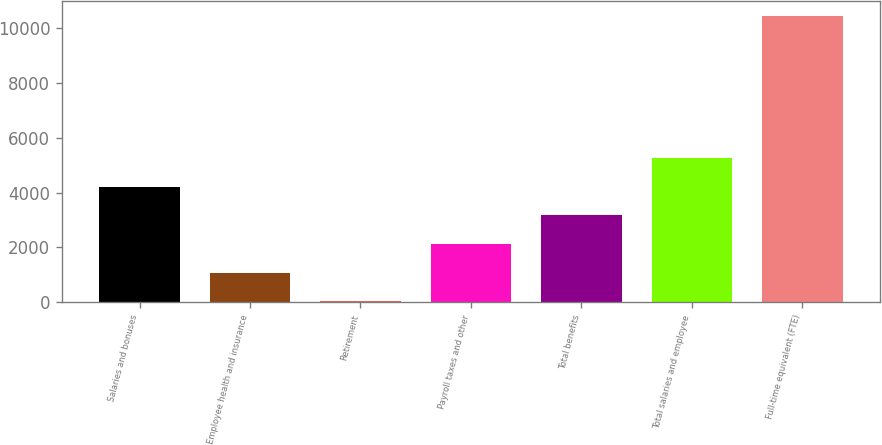Convert chart. <chart><loc_0><loc_0><loc_500><loc_500><bar_chart><fcel>Salaries and bonuses<fcel>Employee health and insurance<fcel>Retirement<fcel>Payroll taxes and other<fcel>Total benefits<fcel>Total salaries and employee<fcel>Full-time equivalent (FTE)<nl><fcel>4204.2<fcel>1080.3<fcel>39<fcel>2121.6<fcel>3162.9<fcel>5245.5<fcel>10452<nl></chart> 